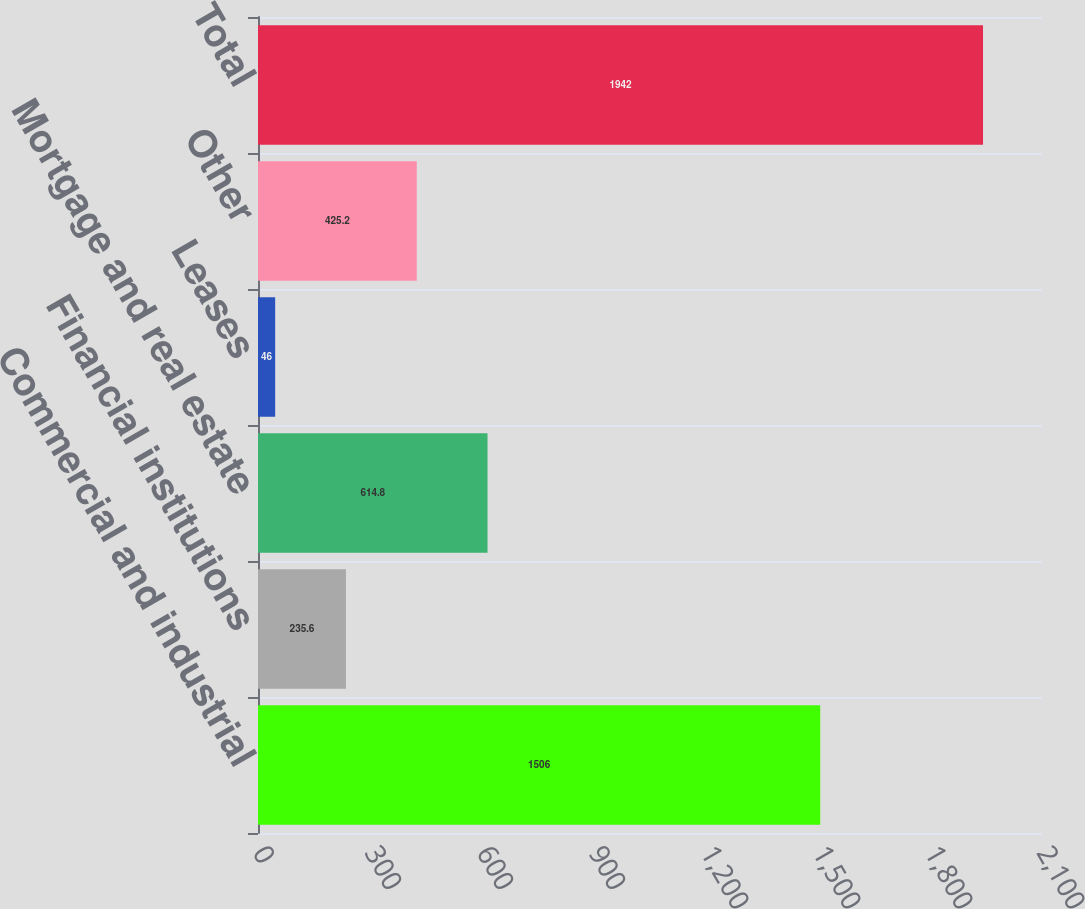Convert chart. <chart><loc_0><loc_0><loc_500><loc_500><bar_chart><fcel>Commercial and industrial<fcel>Financial institutions<fcel>Mortgage and real estate<fcel>Leases<fcel>Other<fcel>Total<nl><fcel>1506<fcel>235.6<fcel>614.8<fcel>46<fcel>425.2<fcel>1942<nl></chart> 